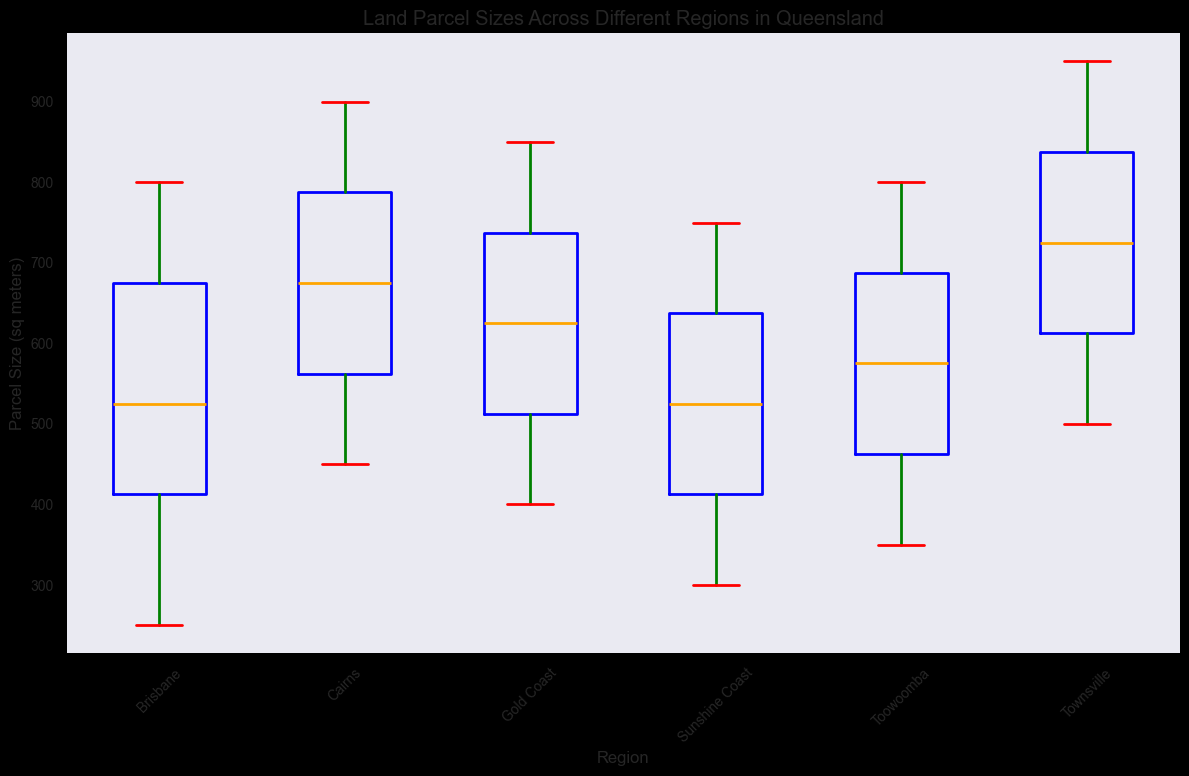What is the median parcel size in Brisbane? To find the median parcel size in Brisbane, look for the center line inside the box for Brisbane on the plot. This line represents the median value.
Answer: 500 How do the interquartile ranges (IQR) of Brisbane and Gold Coast compare? The IQR is the range between the lower quartile (25th percentile) and the upper quartile (75th percentile). Compare these ranges in the box plots for Brisbane and Gold Coast.
Answer: Brisbane has a wider IQR than Gold Coast Which region has the highest maximum parcel size? Look at the top whiskers of the box plots for each region. The region with the highest whisker represents the largest maximum parcel size.
Answer: Townsville Which two regions have the closest median parcel sizes? Compare the median lines (inside the boxes) across different regions. Identify the two regions where these lines are closest in value.
Answer: Cairns and Townsville What is the range of parcel sizes in the Sunshine Coast region? The range is the difference between the maximum and minimum parcel sizes. Identify these from the top and bottom whiskers of the Sunshine Coast box plot.
Answer: 750 - 300 = 450 How does the median parcel size in Toowoomba compare to that in Cairns? Compare the median lines (inside the boxes) of Toowoomba and Cairns to see which is higher.
Answer: Cairns is higher Which region has the smallest interquartile range (IQR)? Identify the region with the smallest distance between the lower and upper quartiles in its box plot.
Answer: Gold Coast Does any region show potential outliers, and if so, which one(s)? Outliers are shown as individual points outside the whiskers of the box plots. Identify any regions with such points.
Answer: No regions display outliers What is the average parcel size for the regions with medians less than 600 sq meters? Identify the regions with medians under 600 sq meters, then calculate the average parcel size for those specific regions.
Answer: Brisbane, Gold Coast, Sunshine Coast, Toowoomba; average size: (summed parcel sizes/number of parcels) Comparing Cairns and Sunshine Coast, which has a greater lower quartile value? The lower quartile is represented by the bottom edge of the box. Compare these values between Cairns and Sunshine Coast.
Answer: Cairns 